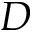Convert formula to latex. <formula><loc_0><loc_0><loc_500><loc_500>D</formula> 